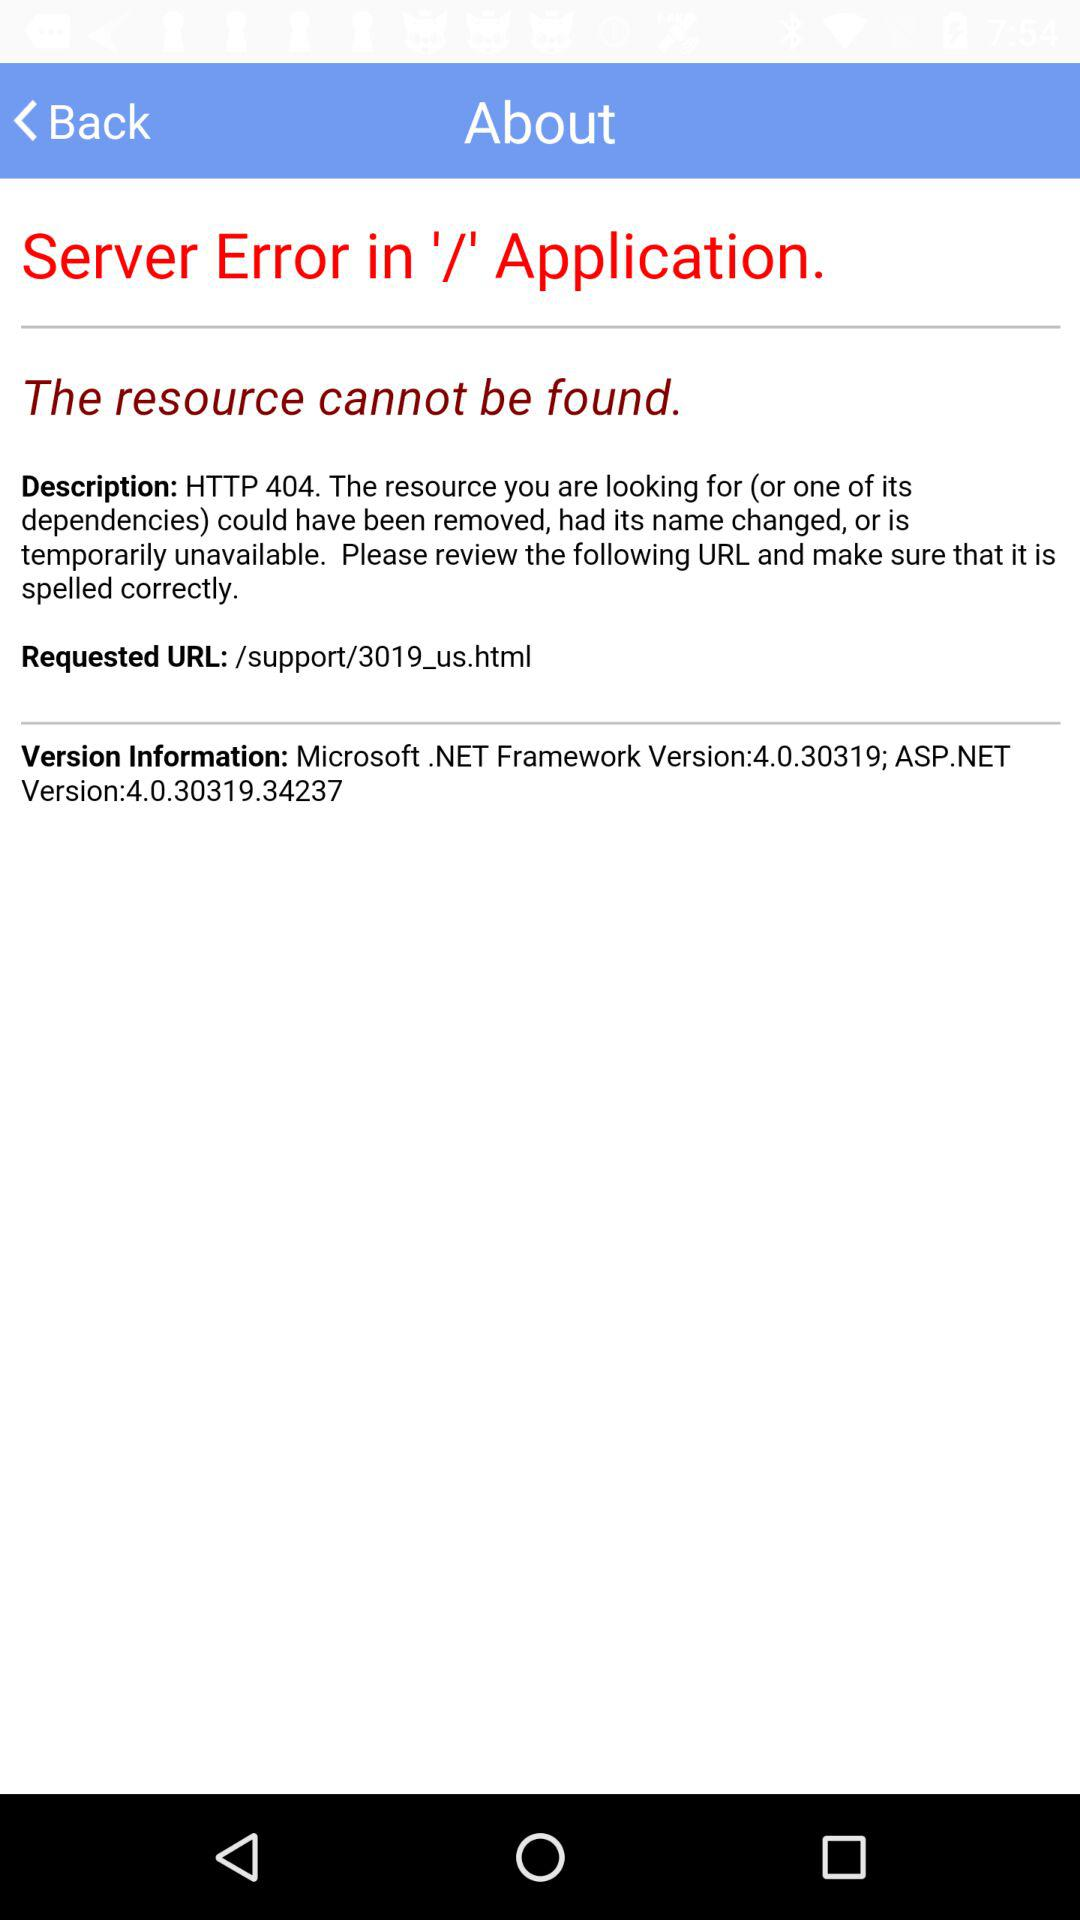What is the version of ASP.NET? The version is 4.0.30319.34237. 